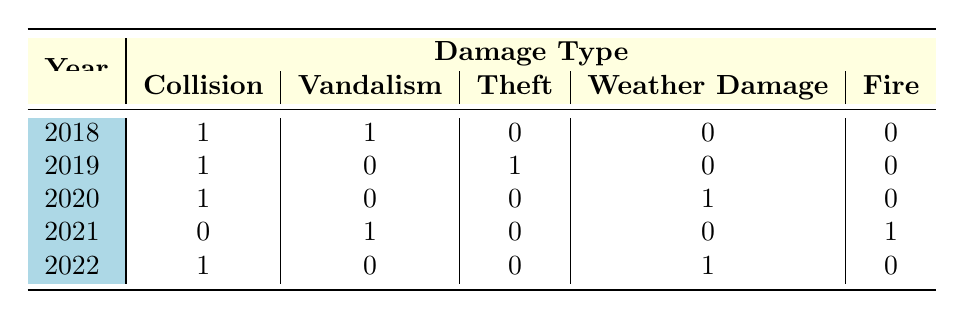What is the total number of claims made in 2018? In 2018, there are two claims recorded: one for Collision and one for Vandalism. Therefore, adding these two claims gives a total of 2 claims made in that year.
Answer: 2 Which damage type was claimed the most in 2020? In 2020, there were two claims: one for Collision and one for Weather Damage. Both claim types have only one occurrence each, so neither can be said to be claimed more than the other.
Answer: Both Collision and Weather Damage Was there a claim for Theft in 2021? Referring to the table for the year 2021, we can see there are no claims recorded under the Theft category. There are claims for Vandalism and Fire, but none for Theft. Therefore, the statement is false.
Answer: No How many years have claims for Vandalism? By looking at the table, the years with claims for Vandalism are 2018 and 2021. Since there are claims for Vandalism in two separate years, we conclude that the count is 2.
Answer: 2 What is the total number of Collision claims from 2018 to 2022? The years with claims for Collision are 2018, 2019, 2020, and 2022. Each of these years has a single claim for Collision, resulting in a total of 4 Collision claims across the specified years.
Answer: 4 Was the claim amount for Fire the highest for any single vehicle model in the dataset? The claim amount for Fire in 2021 is 25000. Looking through the other claims in the dataset, the highest claim amount is 30000 for Collision in 2022. Therefore, the claim for Fire is not the highest.
Answer: No For which year was the only claim made for Weather Damage? The table shows that 2020 and 2022 each had one claim for Weather Damage. However, since 2020's only claim was for Weather Damage while 2022 had both Weather Damage and Collision claims. Thus, 2020 is identified as the year with the only instance for that damage type.
Answer: 2020 How many claims were made for each damage type in 2019? In 2019, there was one claim for Collision and one for Theft, while there were no claims for Vandalism, Weather Damage, or Fire. Adding these, we see a total of 2 claims for that year, but only one for each of Collision and Theft.
Answer: 1 for Collision, 1 for Theft 